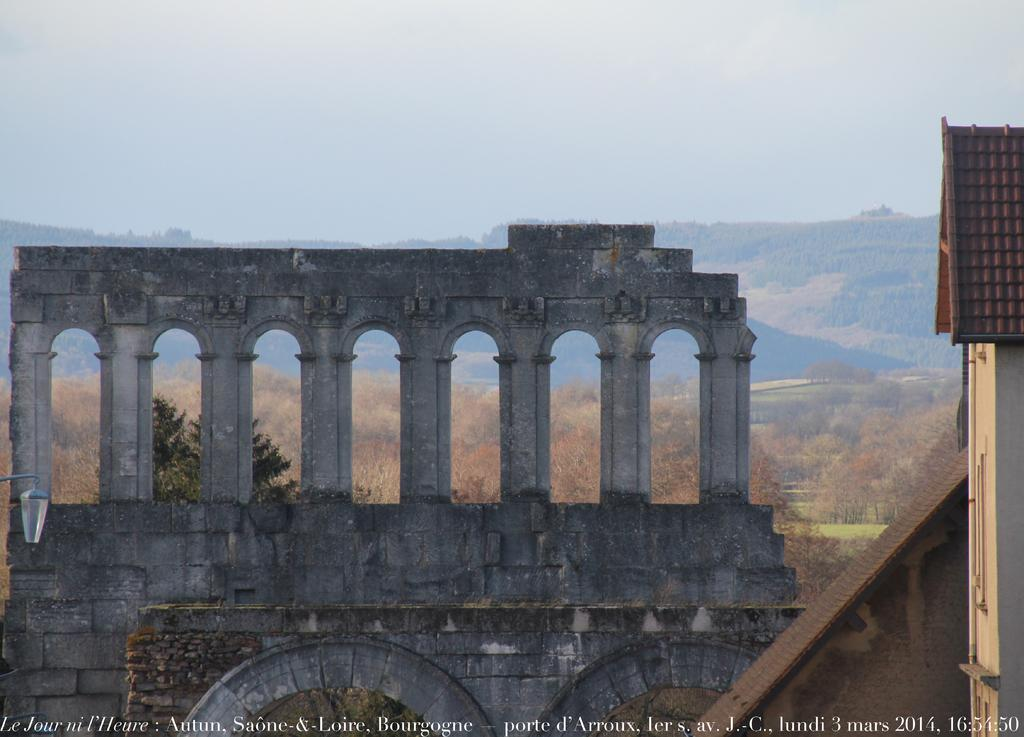What can be seen in the sky in the image? The sky is visible in the image. What type of natural features are present in the image? There are hills in the image. What man-made structure can be seen in the image? There is a monument in the image. What type of vegetation is present in the image? Trees are present in the image. What is visible at the bottom of the image? The ground is visible in the image. What type of hose is being used to exercise the muscle in the image? There is no hose or muscle present in the image. What type of authority figure can be seen in the image? There is no authority figure present in the image. 